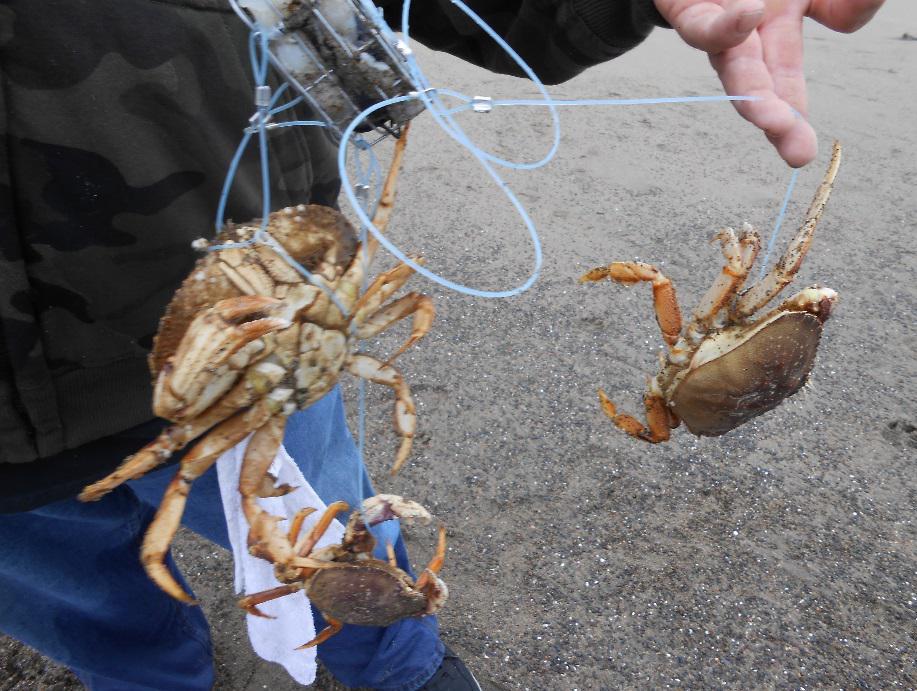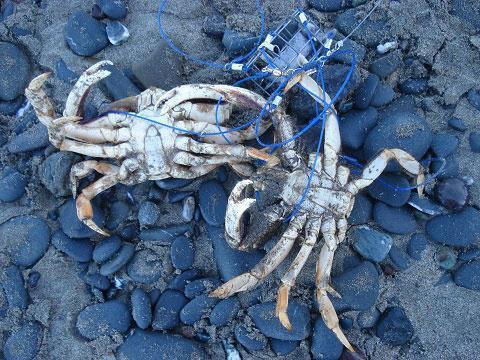The first image is the image on the left, the second image is the image on the right. For the images displayed, is the sentence "One image contains at least one human hand, and the other image includes some crabs and a box formed of a grid of box shapes." factually correct? Answer yes or no. No. The first image is the image on the left, the second image is the image on the right. Considering the images on both sides, is "A person is holding up a set of crabs in one of the images." valid? Answer yes or no. Yes. 